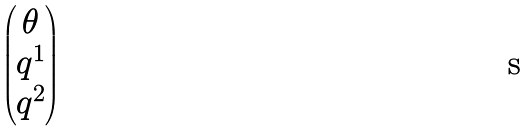<formula> <loc_0><loc_0><loc_500><loc_500>\begin{pmatrix} \theta \\ q ^ { 1 } \\ q ^ { 2 } \end{pmatrix}</formula> 